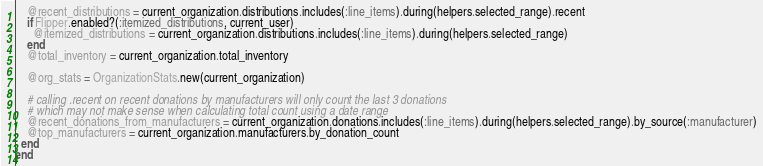Convert code to text. <code><loc_0><loc_0><loc_500><loc_500><_Ruby_>    @recent_distributions = current_organization.distributions.includes(:line_items).during(helpers.selected_range).recent
    if Flipper.enabled?(:itemized_distributions, current_user)
      @itemized_distributions = current_organization.distributions.includes(:line_items).during(helpers.selected_range)
    end
    @total_inventory = current_organization.total_inventory

    @org_stats = OrganizationStats.new(current_organization)

    # calling .recent on recent donations by manufacturers will only count the last 3 donations
    # which may not make sense when calculating total count using a date range
    @recent_donations_from_manufacturers = current_organization.donations.includes(:line_items).during(helpers.selected_range).by_source(:manufacturer)
    @top_manufacturers = current_organization.manufacturers.by_donation_count
  end
end
</code> 